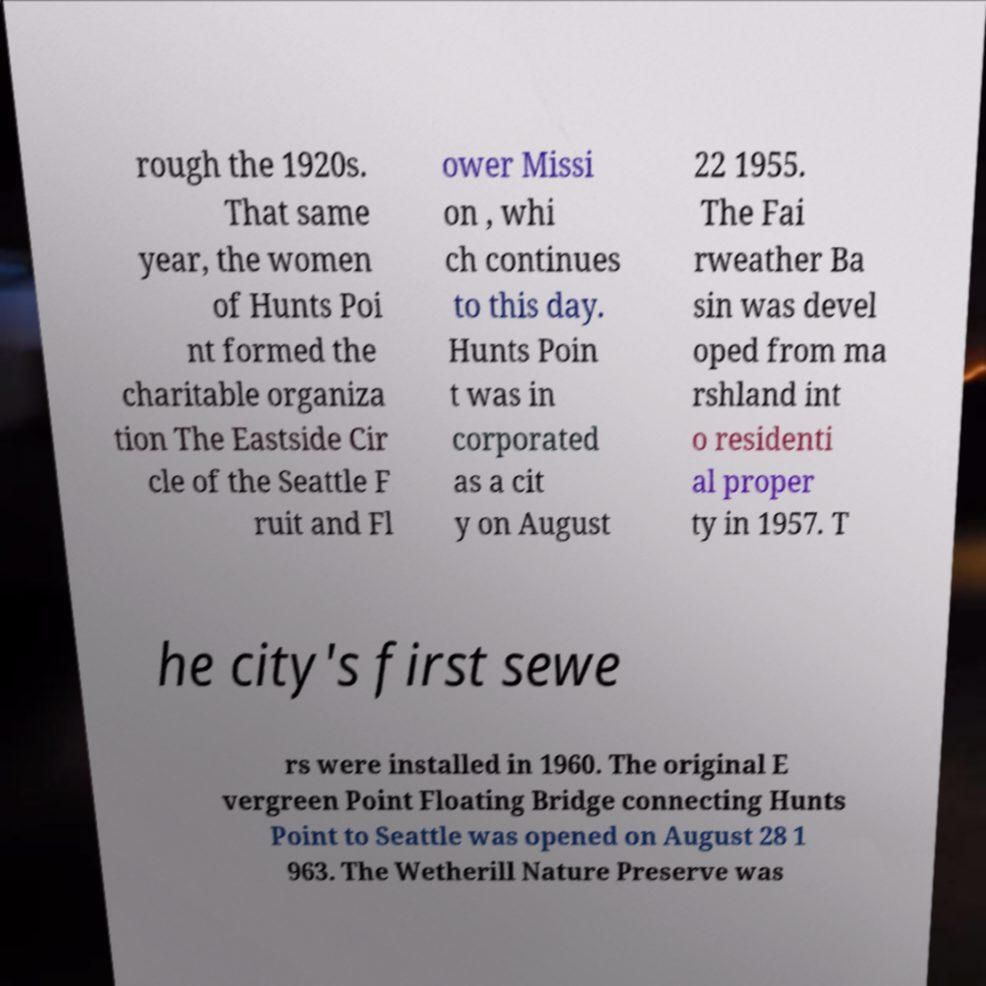Please read and relay the text visible in this image. What does it say? rough the 1920s. That same year, the women of Hunts Poi nt formed the charitable organiza tion The Eastside Cir cle of the Seattle F ruit and Fl ower Missi on , whi ch continues to this day. Hunts Poin t was in corporated as a cit y on August 22 1955. The Fai rweather Ba sin was devel oped from ma rshland int o residenti al proper ty in 1957. T he city's first sewe rs were installed in 1960. The original E vergreen Point Floating Bridge connecting Hunts Point to Seattle was opened on August 28 1 963. The Wetherill Nature Preserve was 